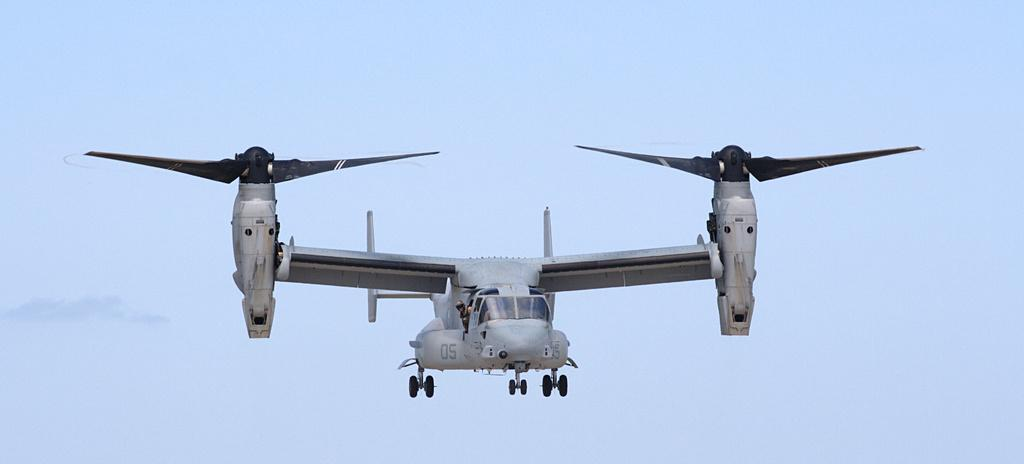What is the main subject of the image? The main subject of the image is an aircraft. Can you describe any other elements in the image? Yes, there is a person in the image. What can be seen in the background of the image? The sky is visible in the image. Where is the desk located in the image? There is no desk present in the image. What type of dolls can be seen interacting with the aircraft in the image? There are no dolls present in the image. 